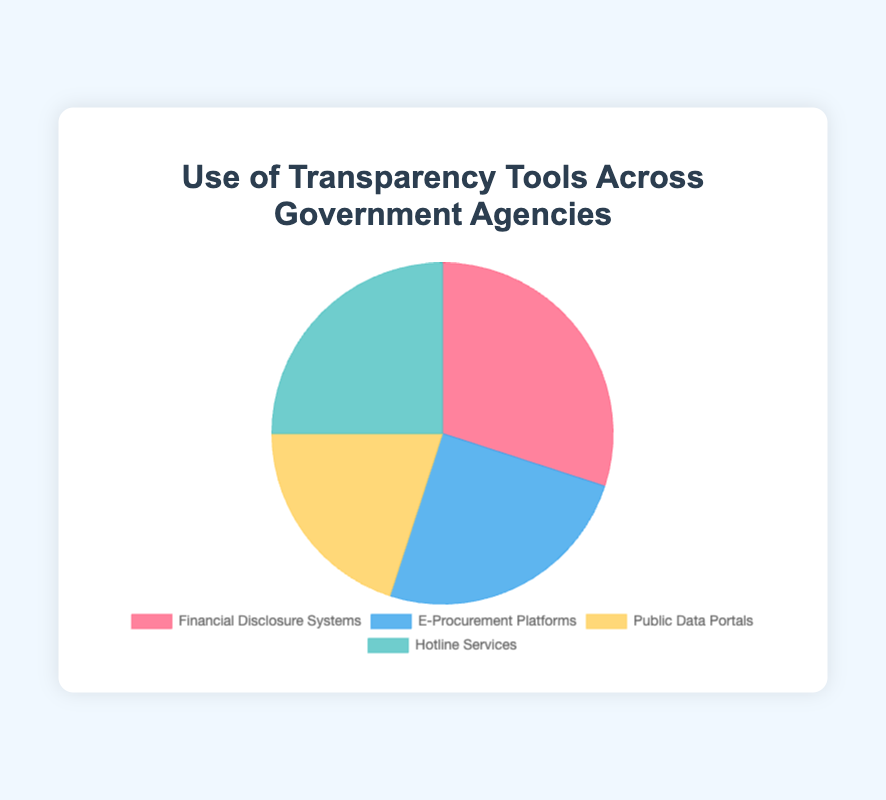What is the most used transparency tool across government agencies? The figure shows that Financial Disclosure Systems has the highest usage percentage at 30%, compared to the other tools.
Answer: Financial Disclosure Systems Which two transparency tools have equal usage percentages? The figure shows that E-Procurement Platforms and Hotline Services both have 25% usage, indicating they have equal usage percentages.
Answer: E-Procurement Platforms and Hotline Services What is the combined usage percentage of E-Procurement Platforms and Hotline Services? According to the figure, E-Procurement Platforms have a 25% usage rate and Hotline Services also have a 25% usage rate. The combined usage is therefore 25% + 25% = 50%.
Answer: 50% Which transparency tool is used less than Financial Disclosure Systems but more than Public Data Portals? By looking at the figure, Hotline Services and E-Procurement Platforms both fit this description with 25%, as Financial Disclosure Systems has 30% and Public Data Portals have 20%.
Answer: E-Procurement Platforms and Hotline Services What is the difference in usage percentage between the least used and most used transparency tools? The least used tool is Public Data Portals with 20%, and the most used is Financial Disclosure Systems with 30%. The difference is 30% - 20% = 10%.
Answer: 10% What percentage of usage do Public Data Portals and Financial Disclosure Systems contribute together? Public Data Portals have a 20% usage rate, and Financial Disclosure Systems have a 30% usage rate. Together, they contribute 20% + 30% = 50%.
Answer: 50% Which transparency tool represented by a blue color in the pie chart and what is its usage percentage? The chart shows that the blue segment represents E-Procurement Platforms with a usage percentage of 25%.
Answer: E-Procurement Platforms, 25% If a new transparency tool is added with a 10% usage percentage, what will be the new average usage percentage of all five tools? The current total percentage for four tools is 100%. Adding a new tool with 10% makes the total 110%. The new average will be 110%/5 = 22%.
Answer: 22% What is the sum of the usage percentages of the tools represented by shades of green and blue? The blue segment represents E-Procurement Platforms with 25%, and one of the green segments represents Hotline Services with 25%. The sum is 25% + 25% = 50%.
Answer: 50% 